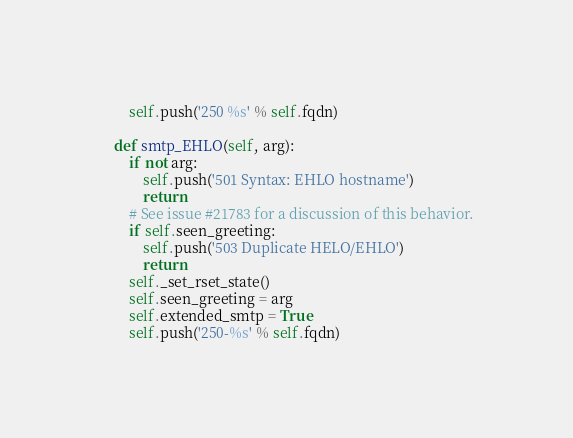<code> <loc_0><loc_0><loc_500><loc_500><_Python_>        self.push('250 %s' % self.fqdn)

    def smtp_EHLO(self, arg):
        if not arg:
            self.push('501 Syntax: EHLO hostname')
            return
        # See issue #21783 for a discussion of this behavior.
        if self.seen_greeting:
            self.push('503 Duplicate HELO/EHLO')
            return
        self._set_rset_state()
        self.seen_greeting = arg
        self.extended_smtp = True
        self.push('250-%s' % self.fqdn)</code> 